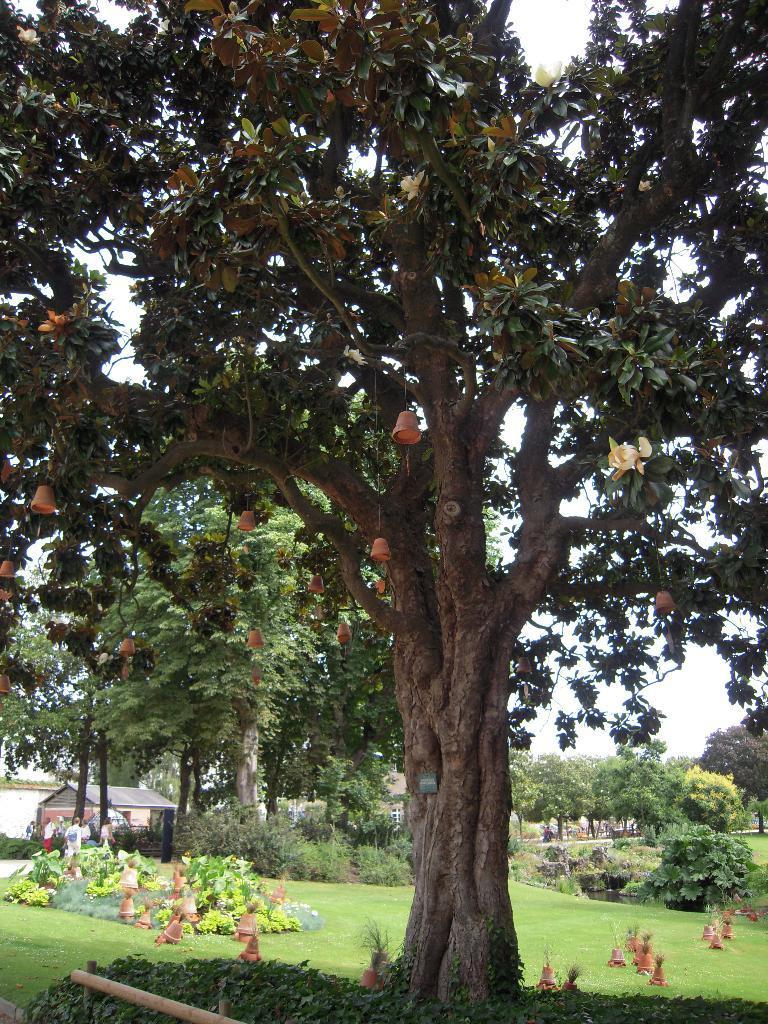In one or two sentences, can you explain what this image depicts? In this image, we can see a tree with decorative pieces. Here we can see few plants, poles, grass, some objects, trees. Here we can see a house, few people. Background there is a sky. 